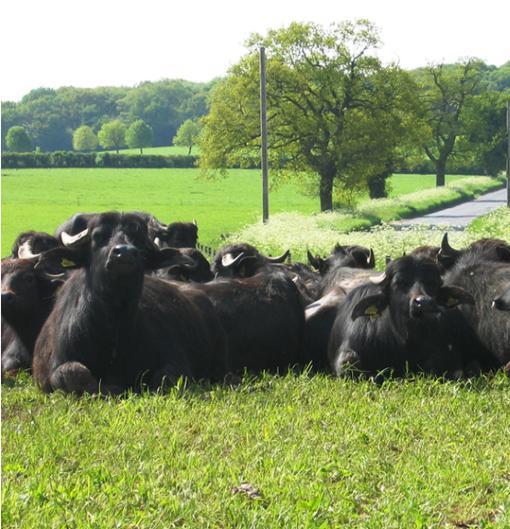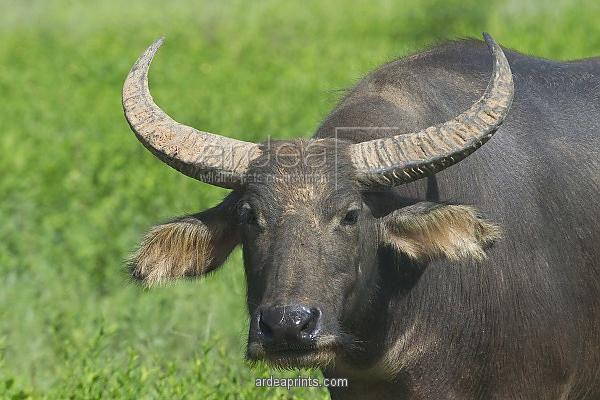The first image is the image on the left, the second image is the image on the right. Examine the images to the left and right. Is the description "In at least one image there is a longhorn bull with his face pointed forward left." accurate? Answer yes or no. Yes. 